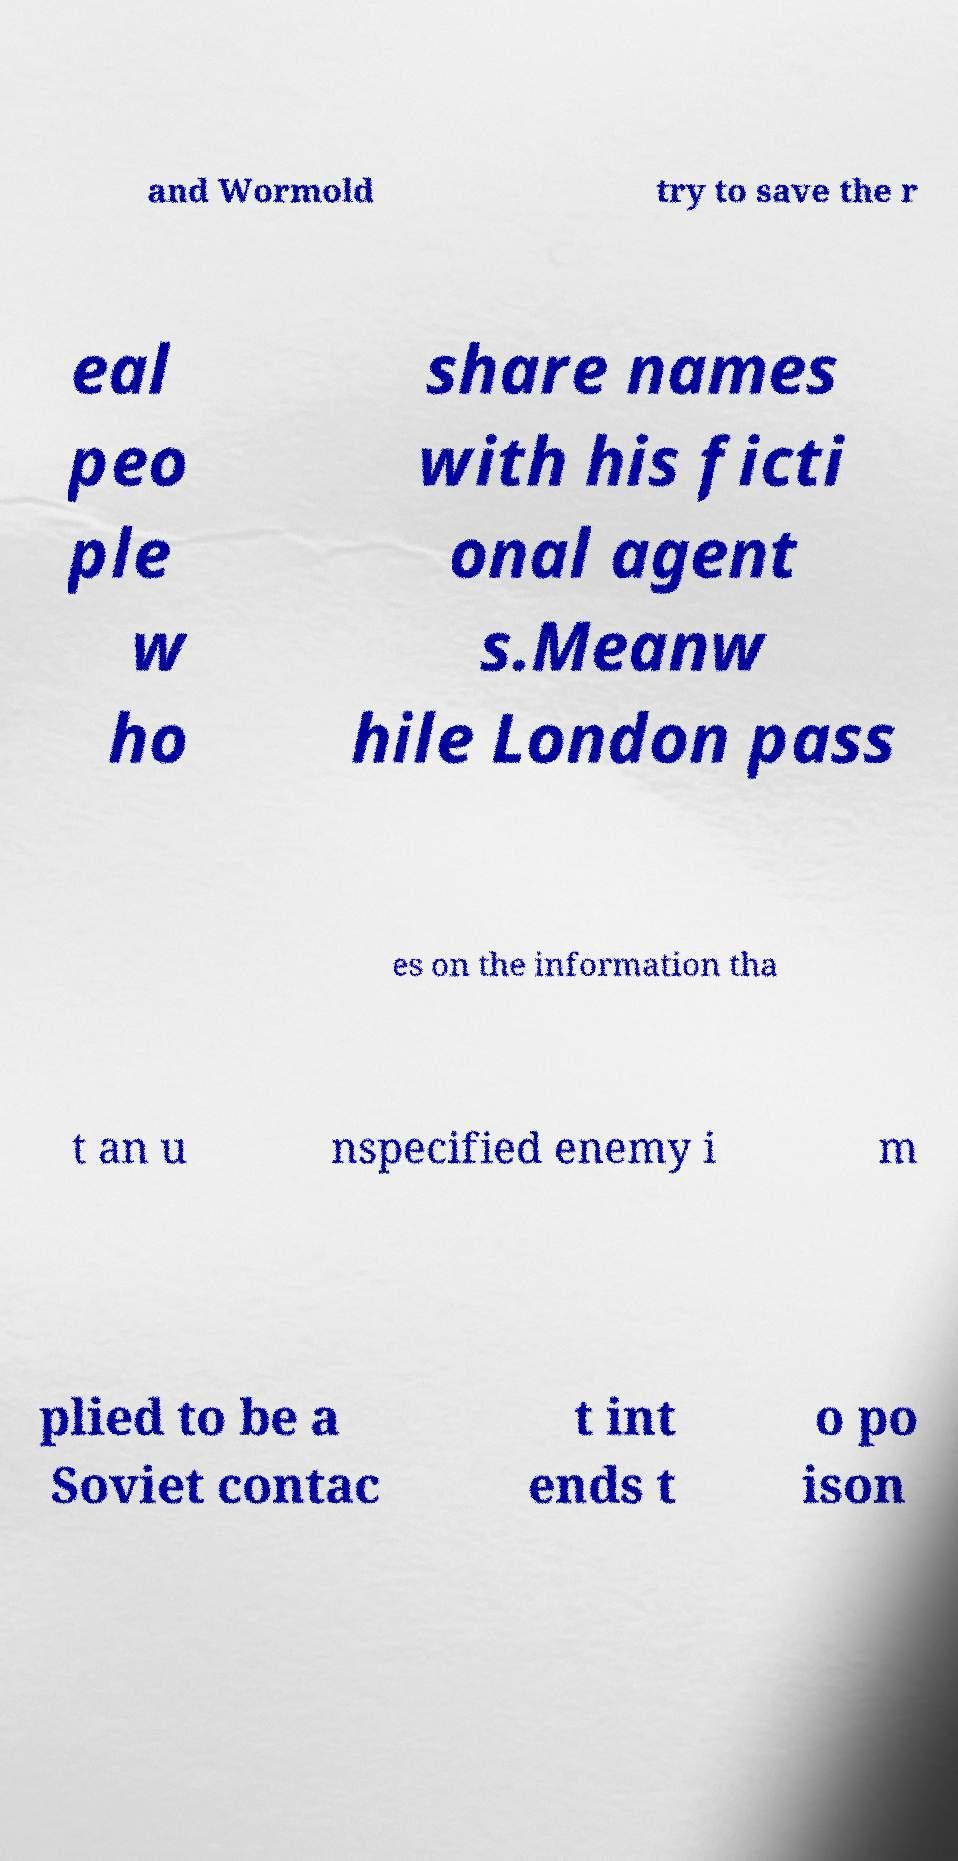For documentation purposes, I need the text within this image transcribed. Could you provide that? and Wormold try to save the r eal peo ple w ho share names with his ficti onal agent s.Meanw hile London pass es on the information tha t an u nspecified enemy i m plied to be a Soviet contac t int ends t o po ison 